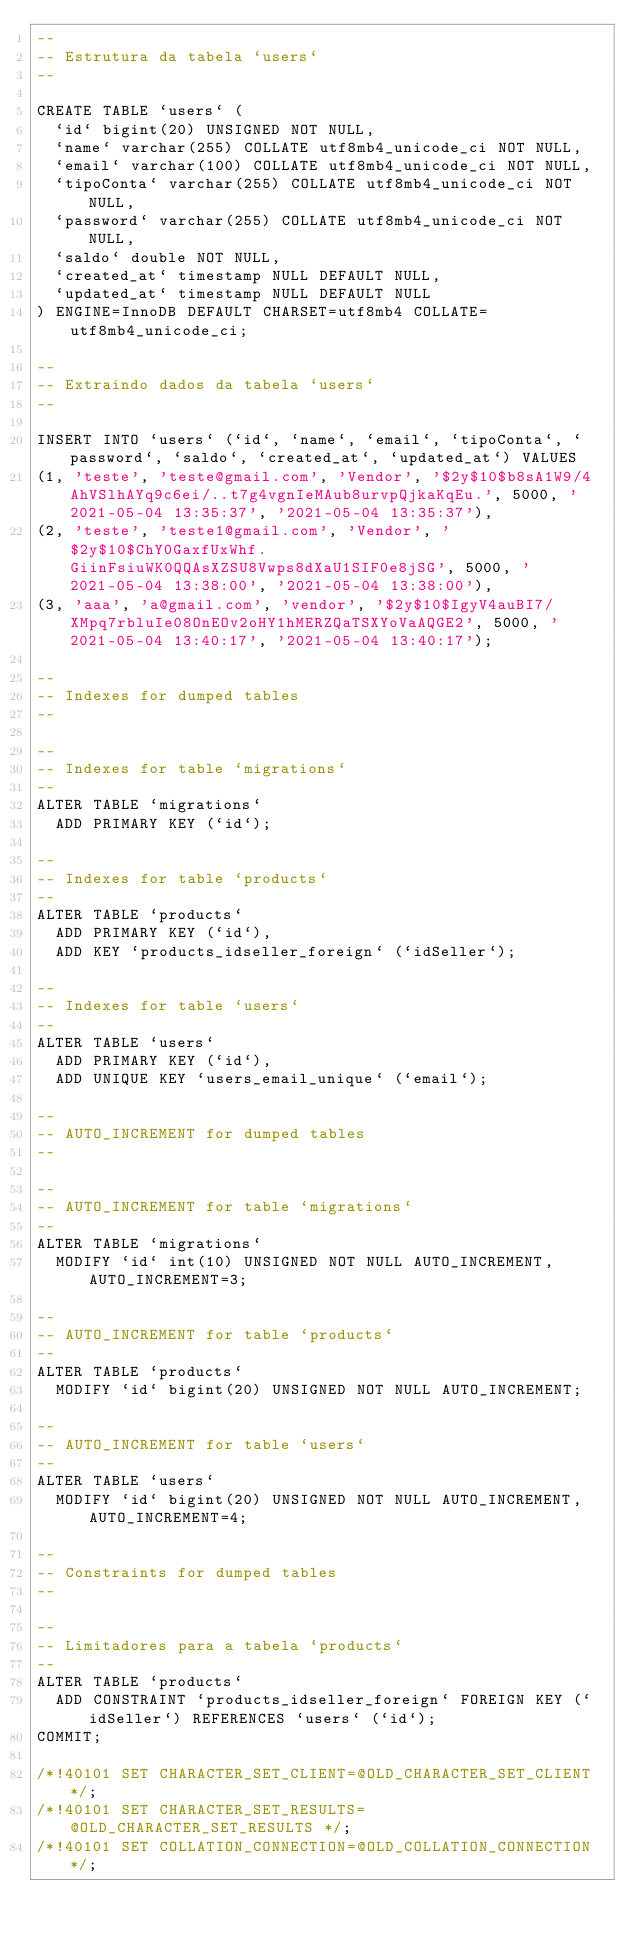<code> <loc_0><loc_0><loc_500><loc_500><_SQL_>--
-- Estrutura da tabela `users`
--

CREATE TABLE `users` (
  `id` bigint(20) UNSIGNED NOT NULL,
  `name` varchar(255) COLLATE utf8mb4_unicode_ci NOT NULL,
  `email` varchar(100) COLLATE utf8mb4_unicode_ci NOT NULL,
  `tipoConta` varchar(255) COLLATE utf8mb4_unicode_ci NOT NULL,
  `password` varchar(255) COLLATE utf8mb4_unicode_ci NOT NULL,
  `saldo` double NOT NULL,
  `created_at` timestamp NULL DEFAULT NULL,
  `updated_at` timestamp NULL DEFAULT NULL
) ENGINE=InnoDB DEFAULT CHARSET=utf8mb4 COLLATE=utf8mb4_unicode_ci;

--
-- Extraindo dados da tabela `users`
--

INSERT INTO `users` (`id`, `name`, `email`, `tipoConta`, `password`, `saldo`, `created_at`, `updated_at`) VALUES
(1, 'teste', 'teste@gmail.com', 'Vendor', '$2y$10$b8sA1W9/4AhVSlhAYq9c6ei/..t7g4vgnIeMAub8urvpQjkaKqEu.', 5000, '2021-05-04 13:35:37', '2021-05-04 13:35:37'),
(2, 'teste', 'teste1@gmail.com', 'Vendor', '$2y$10$ChY0GaxfUxWhf.GiinFsiuWK0QQAsXZSU8Vwps8dXaU1SIF0e8jSG', 5000, '2021-05-04 13:38:00', '2021-05-04 13:38:00'),
(3, 'aaa', 'a@gmail.com', 'vendor', '$2y$10$IgyV4auBI7/XMpq7rbluIe08OnEOv2oHY1hMERZQaTSXYoVaAQGE2', 5000, '2021-05-04 13:40:17', '2021-05-04 13:40:17');

--
-- Indexes for dumped tables
--

--
-- Indexes for table `migrations`
--
ALTER TABLE `migrations`
  ADD PRIMARY KEY (`id`);

--
-- Indexes for table `products`
--
ALTER TABLE `products`
  ADD PRIMARY KEY (`id`),
  ADD KEY `products_idseller_foreign` (`idSeller`);

--
-- Indexes for table `users`
--
ALTER TABLE `users`
  ADD PRIMARY KEY (`id`),
  ADD UNIQUE KEY `users_email_unique` (`email`);

--
-- AUTO_INCREMENT for dumped tables
--

--
-- AUTO_INCREMENT for table `migrations`
--
ALTER TABLE `migrations`
  MODIFY `id` int(10) UNSIGNED NOT NULL AUTO_INCREMENT, AUTO_INCREMENT=3;

--
-- AUTO_INCREMENT for table `products`
--
ALTER TABLE `products`
  MODIFY `id` bigint(20) UNSIGNED NOT NULL AUTO_INCREMENT;

--
-- AUTO_INCREMENT for table `users`
--
ALTER TABLE `users`
  MODIFY `id` bigint(20) UNSIGNED NOT NULL AUTO_INCREMENT, AUTO_INCREMENT=4;

--
-- Constraints for dumped tables
--

--
-- Limitadores para a tabela `products`
--
ALTER TABLE `products`
  ADD CONSTRAINT `products_idseller_foreign` FOREIGN KEY (`idSeller`) REFERENCES `users` (`id`);
COMMIT;

/*!40101 SET CHARACTER_SET_CLIENT=@OLD_CHARACTER_SET_CLIENT */;
/*!40101 SET CHARACTER_SET_RESULTS=@OLD_CHARACTER_SET_RESULTS */;
/*!40101 SET COLLATION_CONNECTION=@OLD_COLLATION_CONNECTION */;
</code> 